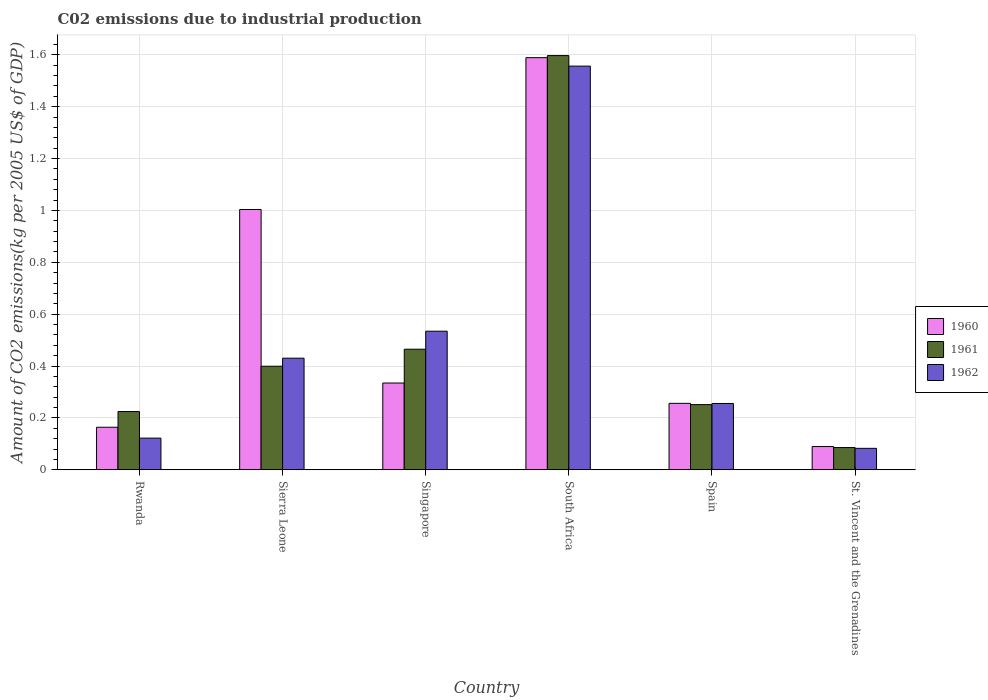How many different coloured bars are there?
Ensure brevity in your answer.  3. Are the number of bars per tick equal to the number of legend labels?
Give a very brief answer. Yes. How many bars are there on the 5th tick from the right?
Provide a short and direct response. 3. What is the label of the 4th group of bars from the left?
Provide a short and direct response. South Africa. In how many cases, is the number of bars for a given country not equal to the number of legend labels?
Ensure brevity in your answer.  0. What is the amount of CO2 emitted due to industrial production in 1962 in Sierra Leone?
Give a very brief answer. 0.43. Across all countries, what is the maximum amount of CO2 emitted due to industrial production in 1962?
Provide a succinct answer. 1.56. Across all countries, what is the minimum amount of CO2 emitted due to industrial production in 1961?
Offer a terse response. 0.09. In which country was the amount of CO2 emitted due to industrial production in 1961 maximum?
Provide a short and direct response. South Africa. In which country was the amount of CO2 emitted due to industrial production in 1961 minimum?
Offer a very short reply. St. Vincent and the Grenadines. What is the total amount of CO2 emitted due to industrial production in 1961 in the graph?
Your answer should be very brief. 3.02. What is the difference between the amount of CO2 emitted due to industrial production in 1961 in Rwanda and that in Singapore?
Your answer should be very brief. -0.24. What is the difference between the amount of CO2 emitted due to industrial production in 1960 in St. Vincent and the Grenadines and the amount of CO2 emitted due to industrial production in 1961 in South Africa?
Your answer should be compact. -1.51. What is the average amount of CO2 emitted due to industrial production in 1962 per country?
Ensure brevity in your answer.  0.5. What is the difference between the amount of CO2 emitted due to industrial production of/in 1960 and amount of CO2 emitted due to industrial production of/in 1962 in Sierra Leone?
Your answer should be very brief. 0.57. In how many countries, is the amount of CO2 emitted due to industrial production in 1961 greater than 0.36 kg?
Offer a very short reply. 3. What is the ratio of the amount of CO2 emitted due to industrial production in 1961 in Sierra Leone to that in Spain?
Make the answer very short. 1.59. Is the amount of CO2 emitted due to industrial production in 1960 in Rwanda less than that in Singapore?
Ensure brevity in your answer.  Yes. What is the difference between the highest and the second highest amount of CO2 emitted due to industrial production in 1962?
Your response must be concise. -1.02. What is the difference between the highest and the lowest amount of CO2 emitted due to industrial production in 1962?
Your response must be concise. 1.47. In how many countries, is the amount of CO2 emitted due to industrial production in 1960 greater than the average amount of CO2 emitted due to industrial production in 1960 taken over all countries?
Your answer should be very brief. 2. Is the sum of the amount of CO2 emitted due to industrial production in 1962 in Rwanda and Sierra Leone greater than the maximum amount of CO2 emitted due to industrial production in 1961 across all countries?
Offer a very short reply. No. What does the 3rd bar from the left in Singapore represents?
Your answer should be compact. 1962. Is it the case that in every country, the sum of the amount of CO2 emitted due to industrial production in 1962 and amount of CO2 emitted due to industrial production in 1960 is greater than the amount of CO2 emitted due to industrial production in 1961?
Keep it short and to the point. Yes. How many bars are there?
Give a very brief answer. 18. Are all the bars in the graph horizontal?
Keep it short and to the point. No. What is the difference between two consecutive major ticks on the Y-axis?
Provide a succinct answer. 0.2. Are the values on the major ticks of Y-axis written in scientific E-notation?
Ensure brevity in your answer.  No. Does the graph contain any zero values?
Keep it short and to the point. No. Does the graph contain grids?
Give a very brief answer. Yes. How many legend labels are there?
Give a very brief answer. 3. How are the legend labels stacked?
Keep it short and to the point. Vertical. What is the title of the graph?
Your answer should be compact. C02 emissions due to industrial production. Does "1970" appear as one of the legend labels in the graph?
Provide a short and direct response. No. What is the label or title of the Y-axis?
Offer a terse response. Amount of CO2 emissions(kg per 2005 US$ of GDP). What is the Amount of CO2 emissions(kg per 2005 US$ of GDP) of 1960 in Rwanda?
Your answer should be compact. 0.16. What is the Amount of CO2 emissions(kg per 2005 US$ of GDP) of 1961 in Rwanda?
Provide a succinct answer. 0.22. What is the Amount of CO2 emissions(kg per 2005 US$ of GDP) in 1962 in Rwanda?
Give a very brief answer. 0.12. What is the Amount of CO2 emissions(kg per 2005 US$ of GDP) of 1960 in Sierra Leone?
Offer a terse response. 1. What is the Amount of CO2 emissions(kg per 2005 US$ of GDP) in 1961 in Sierra Leone?
Offer a terse response. 0.4. What is the Amount of CO2 emissions(kg per 2005 US$ of GDP) in 1962 in Sierra Leone?
Provide a short and direct response. 0.43. What is the Amount of CO2 emissions(kg per 2005 US$ of GDP) in 1960 in Singapore?
Provide a succinct answer. 0.33. What is the Amount of CO2 emissions(kg per 2005 US$ of GDP) in 1961 in Singapore?
Keep it short and to the point. 0.46. What is the Amount of CO2 emissions(kg per 2005 US$ of GDP) of 1962 in Singapore?
Offer a terse response. 0.53. What is the Amount of CO2 emissions(kg per 2005 US$ of GDP) of 1960 in South Africa?
Provide a short and direct response. 1.59. What is the Amount of CO2 emissions(kg per 2005 US$ of GDP) of 1961 in South Africa?
Offer a terse response. 1.6. What is the Amount of CO2 emissions(kg per 2005 US$ of GDP) of 1962 in South Africa?
Your answer should be very brief. 1.56. What is the Amount of CO2 emissions(kg per 2005 US$ of GDP) in 1960 in Spain?
Give a very brief answer. 0.26. What is the Amount of CO2 emissions(kg per 2005 US$ of GDP) of 1961 in Spain?
Give a very brief answer. 0.25. What is the Amount of CO2 emissions(kg per 2005 US$ of GDP) in 1962 in Spain?
Your answer should be compact. 0.26. What is the Amount of CO2 emissions(kg per 2005 US$ of GDP) of 1960 in St. Vincent and the Grenadines?
Offer a very short reply. 0.09. What is the Amount of CO2 emissions(kg per 2005 US$ of GDP) of 1961 in St. Vincent and the Grenadines?
Provide a short and direct response. 0.09. What is the Amount of CO2 emissions(kg per 2005 US$ of GDP) of 1962 in St. Vincent and the Grenadines?
Provide a short and direct response. 0.08. Across all countries, what is the maximum Amount of CO2 emissions(kg per 2005 US$ of GDP) of 1960?
Your answer should be very brief. 1.59. Across all countries, what is the maximum Amount of CO2 emissions(kg per 2005 US$ of GDP) in 1961?
Keep it short and to the point. 1.6. Across all countries, what is the maximum Amount of CO2 emissions(kg per 2005 US$ of GDP) in 1962?
Offer a terse response. 1.56. Across all countries, what is the minimum Amount of CO2 emissions(kg per 2005 US$ of GDP) in 1960?
Offer a terse response. 0.09. Across all countries, what is the minimum Amount of CO2 emissions(kg per 2005 US$ of GDP) of 1961?
Offer a terse response. 0.09. Across all countries, what is the minimum Amount of CO2 emissions(kg per 2005 US$ of GDP) in 1962?
Your response must be concise. 0.08. What is the total Amount of CO2 emissions(kg per 2005 US$ of GDP) in 1960 in the graph?
Offer a terse response. 3.44. What is the total Amount of CO2 emissions(kg per 2005 US$ of GDP) of 1961 in the graph?
Give a very brief answer. 3.02. What is the total Amount of CO2 emissions(kg per 2005 US$ of GDP) of 1962 in the graph?
Ensure brevity in your answer.  2.98. What is the difference between the Amount of CO2 emissions(kg per 2005 US$ of GDP) in 1960 in Rwanda and that in Sierra Leone?
Your answer should be compact. -0.84. What is the difference between the Amount of CO2 emissions(kg per 2005 US$ of GDP) of 1961 in Rwanda and that in Sierra Leone?
Keep it short and to the point. -0.17. What is the difference between the Amount of CO2 emissions(kg per 2005 US$ of GDP) of 1962 in Rwanda and that in Sierra Leone?
Ensure brevity in your answer.  -0.31. What is the difference between the Amount of CO2 emissions(kg per 2005 US$ of GDP) of 1960 in Rwanda and that in Singapore?
Give a very brief answer. -0.17. What is the difference between the Amount of CO2 emissions(kg per 2005 US$ of GDP) in 1961 in Rwanda and that in Singapore?
Provide a short and direct response. -0.24. What is the difference between the Amount of CO2 emissions(kg per 2005 US$ of GDP) of 1962 in Rwanda and that in Singapore?
Provide a succinct answer. -0.41. What is the difference between the Amount of CO2 emissions(kg per 2005 US$ of GDP) of 1960 in Rwanda and that in South Africa?
Ensure brevity in your answer.  -1.42. What is the difference between the Amount of CO2 emissions(kg per 2005 US$ of GDP) in 1961 in Rwanda and that in South Africa?
Provide a short and direct response. -1.37. What is the difference between the Amount of CO2 emissions(kg per 2005 US$ of GDP) in 1962 in Rwanda and that in South Africa?
Your response must be concise. -1.43. What is the difference between the Amount of CO2 emissions(kg per 2005 US$ of GDP) in 1960 in Rwanda and that in Spain?
Keep it short and to the point. -0.09. What is the difference between the Amount of CO2 emissions(kg per 2005 US$ of GDP) in 1961 in Rwanda and that in Spain?
Ensure brevity in your answer.  -0.03. What is the difference between the Amount of CO2 emissions(kg per 2005 US$ of GDP) of 1962 in Rwanda and that in Spain?
Ensure brevity in your answer.  -0.13. What is the difference between the Amount of CO2 emissions(kg per 2005 US$ of GDP) in 1960 in Rwanda and that in St. Vincent and the Grenadines?
Your answer should be compact. 0.07. What is the difference between the Amount of CO2 emissions(kg per 2005 US$ of GDP) in 1961 in Rwanda and that in St. Vincent and the Grenadines?
Offer a terse response. 0.14. What is the difference between the Amount of CO2 emissions(kg per 2005 US$ of GDP) of 1962 in Rwanda and that in St. Vincent and the Grenadines?
Provide a succinct answer. 0.04. What is the difference between the Amount of CO2 emissions(kg per 2005 US$ of GDP) in 1960 in Sierra Leone and that in Singapore?
Ensure brevity in your answer.  0.67. What is the difference between the Amount of CO2 emissions(kg per 2005 US$ of GDP) in 1961 in Sierra Leone and that in Singapore?
Your answer should be compact. -0.07. What is the difference between the Amount of CO2 emissions(kg per 2005 US$ of GDP) of 1962 in Sierra Leone and that in Singapore?
Give a very brief answer. -0.1. What is the difference between the Amount of CO2 emissions(kg per 2005 US$ of GDP) of 1960 in Sierra Leone and that in South Africa?
Your answer should be very brief. -0.59. What is the difference between the Amount of CO2 emissions(kg per 2005 US$ of GDP) in 1961 in Sierra Leone and that in South Africa?
Ensure brevity in your answer.  -1.2. What is the difference between the Amount of CO2 emissions(kg per 2005 US$ of GDP) in 1962 in Sierra Leone and that in South Africa?
Provide a short and direct response. -1.13. What is the difference between the Amount of CO2 emissions(kg per 2005 US$ of GDP) in 1960 in Sierra Leone and that in Spain?
Make the answer very short. 0.75. What is the difference between the Amount of CO2 emissions(kg per 2005 US$ of GDP) of 1961 in Sierra Leone and that in Spain?
Offer a very short reply. 0.15. What is the difference between the Amount of CO2 emissions(kg per 2005 US$ of GDP) of 1962 in Sierra Leone and that in Spain?
Your answer should be very brief. 0.17. What is the difference between the Amount of CO2 emissions(kg per 2005 US$ of GDP) of 1960 in Sierra Leone and that in St. Vincent and the Grenadines?
Keep it short and to the point. 0.91. What is the difference between the Amount of CO2 emissions(kg per 2005 US$ of GDP) in 1961 in Sierra Leone and that in St. Vincent and the Grenadines?
Offer a terse response. 0.31. What is the difference between the Amount of CO2 emissions(kg per 2005 US$ of GDP) in 1962 in Sierra Leone and that in St. Vincent and the Grenadines?
Ensure brevity in your answer.  0.35. What is the difference between the Amount of CO2 emissions(kg per 2005 US$ of GDP) of 1960 in Singapore and that in South Africa?
Keep it short and to the point. -1.25. What is the difference between the Amount of CO2 emissions(kg per 2005 US$ of GDP) of 1961 in Singapore and that in South Africa?
Provide a short and direct response. -1.13. What is the difference between the Amount of CO2 emissions(kg per 2005 US$ of GDP) in 1962 in Singapore and that in South Africa?
Keep it short and to the point. -1.02. What is the difference between the Amount of CO2 emissions(kg per 2005 US$ of GDP) in 1960 in Singapore and that in Spain?
Your answer should be very brief. 0.08. What is the difference between the Amount of CO2 emissions(kg per 2005 US$ of GDP) of 1961 in Singapore and that in Spain?
Keep it short and to the point. 0.21. What is the difference between the Amount of CO2 emissions(kg per 2005 US$ of GDP) in 1962 in Singapore and that in Spain?
Your response must be concise. 0.28. What is the difference between the Amount of CO2 emissions(kg per 2005 US$ of GDP) in 1960 in Singapore and that in St. Vincent and the Grenadines?
Offer a very short reply. 0.24. What is the difference between the Amount of CO2 emissions(kg per 2005 US$ of GDP) in 1961 in Singapore and that in St. Vincent and the Grenadines?
Your answer should be very brief. 0.38. What is the difference between the Amount of CO2 emissions(kg per 2005 US$ of GDP) in 1962 in Singapore and that in St. Vincent and the Grenadines?
Give a very brief answer. 0.45. What is the difference between the Amount of CO2 emissions(kg per 2005 US$ of GDP) of 1960 in South Africa and that in Spain?
Your answer should be very brief. 1.33. What is the difference between the Amount of CO2 emissions(kg per 2005 US$ of GDP) of 1961 in South Africa and that in Spain?
Offer a terse response. 1.35. What is the difference between the Amount of CO2 emissions(kg per 2005 US$ of GDP) of 1962 in South Africa and that in Spain?
Offer a very short reply. 1.3. What is the difference between the Amount of CO2 emissions(kg per 2005 US$ of GDP) of 1960 in South Africa and that in St. Vincent and the Grenadines?
Ensure brevity in your answer.  1.5. What is the difference between the Amount of CO2 emissions(kg per 2005 US$ of GDP) of 1961 in South Africa and that in St. Vincent and the Grenadines?
Offer a terse response. 1.51. What is the difference between the Amount of CO2 emissions(kg per 2005 US$ of GDP) of 1962 in South Africa and that in St. Vincent and the Grenadines?
Provide a succinct answer. 1.47. What is the difference between the Amount of CO2 emissions(kg per 2005 US$ of GDP) in 1960 in Spain and that in St. Vincent and the Grenadines?
Your answer should be compact. 0.17. What is the difference between the Amount of CO2 emissions(kg per 2005 US$ of GDP) in 1961 in Spain and that in St. Vincent and the Grenadines?
Your answer should be compact. 0.17. What is the difference between the Amount of CO2 emissions(kg per 2005 US$ of GDP) in 1962 in Spain and that in St. Vincent and the Grenadines?
Your answer should be very brief. 0.17. What is the difference between the Amount of CO2 emissions(kg per 2005 US$ of GDP) in 1960 in Rwanda and the Amount of CO2 emissions(kg per 2005 US$ of GDP) in 1961 in Sierra Leone?
Ensure brevity in your answer.  -0.24. What is the difference between the Amount of CO2 emissions(kg per 2005 US$ of GDP) in 1960 in Rwanda and the Amount of CO2 emissions(kg per 2005 US$ of GDP) in 1962 in Sierra Leone?
Your response must be concise. -0.27. What is the difference between the Amount of CO2 emissions(kg per 2005 US$ of GDP) in 1961 in Rwanda and the Amount of CO2 emissions(kg per 2005 US$ of GDP) in 1962 in Sierra Leone?
Make the answer very short. -0.21. What is the difference between the Amount of CO2 emissions(kg per 2005 US$ of GDP) in 1960 in Rwanda and the Amount of CO2 emissions(kg per 2005 US$ of GDP) in 1961 in Singapore?
Keep it short and to the point. -0.3. What is the difference between the Amount of CO2 emissions(kg per 2005 US$ of GDP) of 1960 in Rwanda and the Amount of CO2 emissions(kg per 2005 US$ of GDP) of 1962 in Singapore?
Provide a short and direct response. -0.37. What is the difference between the Amount of CO2 emissions(kg per 2005 US$ of GDP) in 1961 in Rwanda and the Amount of CO2 emissions(kg per 2005 US$ of GDP) in 1962 in Singapore?
Give a very brief answer. -0.31. What is the difference between the Amount of CO2 emissions(kg per 2005 US$ of GDP) of 1960 in Rwanda and the Amount of CO2 emissions(kg per 2005 US$ of GDP) of 1961 in South Africa?
Ensure brevity in your answer.  -1.43. What is the difference between the Amount of CO2 emissions(kg per 2005 US$ of GDP) in 1960 in Rwanda and the Amount of CO2 emissions(kg per 2005 US$ of GDP) in 1962 in South Africa?
Provide a short and direct response. -1.39. What is the difference between the Amount of CO2 emissions(kg per 2005 US$ of GDP) in 1961 in Rwanda and the Amount of CO2 emissions(kg per 2005 US$ of GDP) in 1962 in South Africa?
Provide a succinct answer. -1.33. What is the difference between the Amount of CO2 emissions(kg per 2005 US$ of GDP) of 1960 in Rwanda and the Amount of CO2 emissions(kg per 2005 US$ of GDP) of 1961 in Spain?
Provide a succinct answer. -0.09. What is the difference between the Amount of CO2 emissions(kg per 2005 US$ of GDP) in 1960 in Rwanda and the Amount of CO2 emissions(kg per 2005 US$ of GDP) in 1962 in Spain?
Your response must be concise. -0.09. What is the difference between the Amount of CO2 emissions(kg per 2005 US$ of GDP) of 1961 in Rwanda and the Amount of CO2 emissions(kg per 2005 US$ of GDP) of 1962 in Spain?
Make the answer very short. -0.03. What is the difference between the Amount of CO2 emissions(kg per 2005 US$ of GDP) in 1960 in Rwanda and the Amount of CO2 emissions(kg per 2005 US$ of GDP) in 1961 in St. Vincent and the Grenadines?
Give a very brief answer. 0.08. What is the difference between the Amount of CO2 emissions(kg per 2005 US$ of GDP) in 1960 in Rwanda and the Amount of CO2 emissions(kg per 2005 US$ of GDP) in 1962 in St. Vincent and the Grenadines?
Offer a terse response. 0.08. What is the difference between the Amount of CO2 emissions(kg per 2005 US$ of GDP) in 1961 in Rwanda and the Amount of CO2 emissions(kg per 2005 US$ of GDP) in 1962 in St. Vincent and the Grenadines?
Offer a very short reply. 0.14. What is the difference between the Amount of CO2 emissions(kg per 2005 US$ of GDP) in 1960 in Sierra Leone and the Amount of CO2 emissions(kg per 2005 US$ of GDP) in 1961 in Singapore?
Keep it short and to the point. 0.54. What is the difference between the Amount of CO2 emissions(kg per 2005 US$ of GDP) of 1960 in Sierra Leone and the Amount of CO2 emissions(kg per 2005 US$ of GDP) of 1962 in Singapore?
Ensure brevity in your answer.  0.47. What is the difference between the Amount of CO2 emissions(kg per 2005 US$ of GDP) in 1961 in Sierra Leone and the Amount of CO2 emissions(kg per 2005 US$ of GDP) in 1962 in Singapore?
Provide a short and direct response. -0.14. What is the difference between the Amount of CO2 emissions(kg per 2005 US$ of GDP) of 1960 in Sierra Leone and the Amount of CO2 emissions(kg per 2005 US$ of GDP) of 1961 in South Africa?
Offer a very short reply. -0.59. What is the difference between the Amount of CO2 emissions(kg per 2005 US$ of GDP) of 1960 in Sierra Leone and the Amount of CO2 emissions(kg per 2005 US$ of GDP) of 1962 in South Africa?
Your answer should be compact. -0.55. What is the difference between the Amount of CO2 emissions(kg per 2005 US$ of GDP) in 1961 in Sierra Leone and the Amount of CO2 emissions(kg per 2005 US$ of GDP) in 1962 in South Africa?
Your answer should be compact. -1.16. What is the difference between the Amount of CO2 emissions(kg per 2005 US$ of GDP) in 1960 in Sierra Leone and the Amount of CO2 emissions(kg per 2005 US$ of GDP) in 1961 in Spain?
Your response must be concise. 0.75. What is the difference between the Amount of CO2 emissions(kg per 2005 US$ of GDP) in 1960 in Sierra Leone and the Amount of CO2 emissions(kg per 2005 US$ of GDP) in 1962 in Spain?
Provide a short and direct response. 0.75. What is the difference between the Amount of CO2 emissions(kg per 2005 US$ of GDP) in 1961 in Sierra Leone and the Amount of CO2 emissions(kg per 2005 US$ of GDP) in 1962 in Spain?
Make the answer very short. 0.14. What is the difference between the Amount of CO2 emissions(kg per 2005 US$ of GDP) of 1960 in Sierra Leone and the Amount of CO2 emissions(kg per 2005 US$ of GDP) of 1961 in St. Vincent and the Grenadines?
Provide a succinct answer. 0.92. What is the difference between the Amount of CO2 emissions(kg per 2005 US$ of GDP) in 1960 in Sierra Leone and the Amount of CO2 emissions(kg per 2005 US$ of GDP) in 1962 in St. Vincent and the Grenadines?
Give a very brief answer. 0.92. What is the difference between the Amount of CO2 emissions(kg per 2005 US$ of GDP) of 1961 in Sierra Leone and the Amount of CO2 emissions(kg per 2005 US$ of GDP) of 1962 in St. Vincent and the Grenadines?
Offer a terse response. 0.32. What is the difference between the Amount of CO2 emissions(kg per 2005 US$ of GDP) in 1960 in Singapore and the Amount of CO2 emissions(kg per 2005 US$ of GDP) in 1961 in South Africa?
Provide a short and direct response. -1.26. What is the difference between the Amount of CO2 emissions(kg per 2005 US$ of GDP) in 1960 in Singapore and the Amount of CO2 emissions(kg per 2005 US$ of GDP) in 1962 in South Africa?
Provide a short and direct response. -1.22. What is the difference between the Amount of CO2 emissions(kg per 2005 US$ of GDP) in 1961 in Singapore and the Amount of CO2 emissions(kg per 2005 US$ of GDP) in 1962 in South Africa?
Your answer should be very brief. -1.09. What is the difference between the Amount of CO2 emissions(kg per 2005 US$ of GDP) of 1960 in Singapore and the Amount of CO2 emissions(kg per 2005 US$ of GDP) of 1961 in Spain?
Keep it short and to the point. 0.08. What is the difference between the Amount of CO2 emissions(kg per 2005 US$ of GDP) of 1960 in Singapore and the Amount of CO2 emissions(kg per 2005 US$ of GDP) of 1962 in Spain?
Keep it short and to the point. 0.08. What is the difference between the Amount of CO2 emissions(kg per 2005 US$ of GDP) in 1961 in Singapore and the Amount of CO2 emissions(kg per 2005 US$ of GDP) in 1962 in Spain?
Your response must be concise. 0.21. What is the difference between the Amount of CO2 emissions(kg per 2005 US$ of GDP) in 1960 in Singapore and the Amount of CO2 emissions(kg per 2005 US$ of GDP) in 1961 in St. Vincent and the Grenadines?
Make the answer very short. 0.25. What is the difference between the Amount of CO2 emissions(kg per 2005 US$ of GDP) in 1960 in Singapore and the Amount of CO2 emissions(kg per 2005 US$ of GDP) in 1962 in St. Vincent and the Grenadines?
Ensure brevity in your answer.  0.25. What is the difference between the Amount of CO2 emissions(kg per 2005 US$ of GDP) of 1961 in Singapore and the Amount of CO2 emissions(kg per 2005 US$ of GDP) of 1962 in St. Vincent and the Grenadines?
Give a very brief answer. 0.38. What is the difference between the Amount of CO2 emissions(kg per 2005 US$ of GDP) of 1960 in South Africa and the Amount of CO2 emissions(kg per 2005 US$ of GDP) of 1961 in Spain?
Your response must be concise. 1.34. What is the difference between the Amount of CO2 emissions(kg per 2005 US$ of GDP) of 1960 in South Africa and the Amount of CO2 emissions(kg per 2005 US$ of GDP) of 1962 in Spain?
Offer a very short reply. 1.33. What is the difference between the Amount of CO2 emissions(kg per 2005 US$ of GDP) of 1961 in South Africa and the Amount of CO2 emissions(kg per 2005 US$ of GDP) of 1962 in Spain?
Your answer should be compact. 1.34. What is the difference between the Amount of CO2 emissions(kg per 2005 US$ of GDP) in 1960 in South Africa and the Amount of CO2 emissions(kg per 2005 US$ of GDP) in 1961 in St. Vincent and the Grenadines?
Give a very brief answer. 1.5. What is the difference between the Amount of CO2 emissions(kg per 2005 US$ of GDP) in 1960 in South Africa and the Amount of CO2 emissions(kg per 2005 US$ of GDP) in 1962 in St. Vincent and the Grenadines?
Provide a succinct answer. 1.51. What is the difference between the Amount of CO2 emissions(kg per 2005 US$ of GDP) of 1961 in South Africa and the Amount of CO2 emissions(kg per 2005 US$ of GDP) of 1962 in St. Vincent and the Grenadines?
Make the answer very short. 1.51. What is the difference between the Amount of CO2 emissions(kg per 2005 US$ of GDP) of 1960 in Spain and the Amount of CO2 emissions(kg per 2005 US$ of GDP) of 1961 in St. Vincent and the Grenadines?
Provide a succinct answer. 0.17. What is the difference between the Amount of CO2 emissions(kg per 2005 US$ of GDP) in 1960 in Spain and the Amount of CO2 emissions(kg per 2005 US$ of GDP) in 1962 in St. Vincent and the Grenadines?
Your response must be concise. 0.17. What is the difference between the Amount of CO2 emissions(kg per 2005 US$ of GDP) of 1961 in Spain and the Amount of CO2 emissions(kg per 2005 US$ of GDP) of 1962 in St. Vincent and the Grenadines?
Provide a succinct answer. 0.17. What is the average Amount of CO2 emissions(kg per 2005 US$ of GDP) in 1960 per country?
Provide a short and direct response. 0.57. What is the average Amount of CO2 emissions(kg per 2005 US$ of GDP) in 1961 per country?
Your response must be concise. 0.5. What is the average Amount of CO2 emissions(kg per 2005 US$ of GDP) of 1962 per country?
Make the answer very short. 0.5. What is the difference between the Amount of CO2 emissions(kg per 2005 US$ of GDP) of 1960 and Amount of CO2 emissions(kg per 2005 US$ of GDP) of 1961 in Rwanda?
Provide a succinct answer. -0.06. What is the difference between the Amount of CO2 emissions(kg per 2005 US$ of GDP) in 1960 and Amount of CO2 emissions(kg per 2005 US$ of GDP) in 1962 in Rwanda?
Give a very brief answer. 0.04. What is the difference between the Amount of CO2 emissions(kg per 2005 US$ of GDP) of 1961 and Amount of CO2 emissions(kg per 2005 US$ of GDP) of 1962 in Rwanda?
Your answer should be very brief. 0.1. What is the difference between the Amount of CO2 emissions(kg per 2005 US$ of GDP) in 1960 and Amount of CO2 emissions(kg per 2005 US$ of GDP) in 1961 in Sierra Leone?
Ensure brevity in your answer.  0.6. What is the difference between the Amount of CO2 emissions(kg per 2005 US$ of GDP) in 1960 and Amount of CO2 emissions(kg per 2005 US$ of GDP) in 1962 in Sierra Leone?
Your answer should be compact. 0.57. What is the difference between the Amount of CO2 emissions(kg per 2005 US$ of GDP) of 1961 and Amount of CO2 emissions(kg per 2005 US$ of GDP) of 1962 in Sierra Leone?
Offer a very short reply. -0.03. What is the difference between the Amount of CO2 emissions(kg per 2005 US$ of GDP) of 1960 and Amount of CO2 emissions(kg per 2005 US$ of GDP) of 1961 in Singapore?
Keep it short and to the point. -0.13. What is the difference between the Amount of CO2 emissions(kg per 2005 US$ of GDP) in 1960 and Amount of CO2 emissions(kg per 2005 US$ of GDP) in 1962 in Singapore?
Your answer should be very brief. -0.2. What is the difference between the Amount of CO2 emissions(kg per 2005 US$ of GDP) in 1961 and Amount of CO2 emissions(kg per 2005 US$ of GDP) in 1962 in Singapore?
Offer a terse response. -0.07. What is the difference between the Amount of CO2 emissions(kg per 2005 US$ of GDP) in 1960 and Amount of CO2 emissions(kg per 2005 US$ of GDP) in 1961 in South Africa?
Ensure brevity in your answer.  -0.01. What is the difference between the Amount of CO2 emissions(kg per 2005 US$ of GDP) in 1960 and Amount of CO2 emissions(kg per 2005 US$ of GDP) in 1962 in South Africa?
Offer a terse response. 0.03. What is the difference between the Amount of CO2 emissions(kg per 2005 US$ of GDP) in 1961 and Amount of CO2 emissions(kg per 2005 US$ of GDP) in 1962 in South Africa?
Your answer should be very brief. 0.04. What is the difference between the Amount of CO2 emissions(kg per 2005 US$ of GDP) of 1960 and Amount of CO2 emissions(kg per 2005 US$ of GDP) of 1961 in Spain?
Offer a very short reply. 0. What is the difference between the Amount of CO2 emissions(kg per 2005 US$ of GDP) in 1960 and Amount of CO2 emissions(kg per 2005 US$ of GDP) in 1962 in Spain?
Make the answer very short. 0. What is the difference between the Amount of CO2 emissions(kg per 2005 US$ of GDP) in 1961 and Amount of CO2 emissions(kg per 2005 US$ of GDP) in 1962 in Spain?
Offer a terse response. -0. What is the difference between the Amount of CO2 emissions(kg per 2005 US$ of GDP) of 1960 and Amount of CO2 emissions(kg per 2005 US$ of GDP) of 1961 in St. Vincent and the Grenadines?
Give a very brief answer. 0. What is the difference between the Amount of CO2 emissions(kg per 2005 US$ of GDP) of 1960 and Amount of CO2 emissions(kg per 2005 US$ of GDP) of 1962 in St. Vincent and the Grenadines?
Provide a short and direct response. 0.01. What is the difference between the Amount of CO2 emissions(kg per 2005 US$ of GDP) of 1961 and Amount of CO2 emissions(kg per 2005 US$ of GDP) of 1962 in St. Vincent and the Grenadines?
Keep it short and to the point. 0. What is the ratio of the Amount of CO2 emissions(kg per 2005 US$ of GDP) of 1960 in Rwanda to that in Sierra Leone?
Your answer should be compact. 0.16. What is the ratio of the Amount of CO2 emissions(kg per 2005 US$ of GDP) of 1961 in Rwanda to that in Sierra Leone?
Keep it short and to the point. 0.56. What is the ratio of the Amount of CO2 emissions(kg per 2005 US$ of GDP) in 1962 in Rwanda to that in Sierra Leone?
Your answer should be compact. 0.28. What is the ratio of the Amount of CO2 emissions(kg per 2005 US$ of GDP) of 1960 in Rwanda to that in Singapore?
Ensure brevity in your answer.  0.49. What is the ratio of the Amount of CO2 emissions(kg per 2005 US$ of GDP) of 1961 in Rwanda to that in Singapore?
Provide a succinct answer. 0.48. What is the ratio of the Amount of CO2 emissions(kg per 2005 US$ of GDP) of 1962 in Rwanda to that in Singapore?
Keep it short and to the point. 0.23. What is the ratio of the Amount of CO2 emissions(kg per 2005 US$ of GDP) of 1960 in Rwanda to that in South Africa?
Provide a succinct answer. 0.1. What is the ratio of the Amount of CO2 emissions(kg per 2005 US$ of GDP) in 1961 in Rwanda to that in South Africa?
Ensure brevity in your answer.  0.14. What is the ratio of the Amount of CO2 emissions(kg per 2005 US$ of GDP) of 1962 in Rwanda to that in South Africa?
Offer a terse response. 0.08. What is the ratio of the Amount of CO2 emissions(kg per 2005 US$ of GDP) in 1960 in Rwanda to that in Spain?
Provide a succinct answer. 0.64. What is the ratio of the Amount of CO2 emissions(kg per 2005 US$ of GDP) in 1961 in Rwanda to that in Spain?
Offer a terse response. 0.89. What is the ratio of the Amount of CO2 emissions(kg per 2005 US$ of GDP) in 1962 in Rwanda to that in Spain?
Give a very brief answer. 0.48. What is the ratio of the Amount of CO2 emissions(kg per 2005 US$ of GDP) of 1960 in Rwanda to that in St. Vincent and the Grenadines?
Your answer should be very brief. 1.83. What is the ratio of the Amount of CO2 emissions(kg per 2005 US$ of GDP) of 1961 in Rwanda to that in St. Vincent and the Grenadines?
Keep it short and to the point. 2.62. What is the ratio of the Amount of CO2 emissions(kg per 2005 US$ of GDP) in 1962 in Rwanda to that in St. Vincent and the Grenadines?
Ensure brevity in your answer.  1.48. What is the ratio of the Amount of CO2 emissions(kg per 2005 US$ of GDP) in 1960 in Sierra Leone to that in Singapore?
Offer a very short reply. 3. What is the ratio of the Amount of CO2 emissions(kg per 2005 US$ of GDP) in 1961 in Sierra Leone to that in Singapore?
Ensure brevity in your answer.  0.86. What is the ratio of the Amount of CO2 emissions(kg per 2005 US$ of GDP) in 1962 in Sierra Leone to that in Singapore?
Offer a terse response. 0.81. What is the ratio of the Amount of CO2 emissions(kg per 2005 US$ of GDP) in 1960 in Sierra Leone to that in South Africa?
Offer a terse response. 0.63. What is the ratio of the Amount of CO2 emissions(kg per 2005 US$ of GDP) of 1961 in Sierra Leone to that in South Africa?
Your answer should be compact. 0.25. What is the ratio of the Amount of CO2 emissions(kg per 2005 US$ of GDP) in 1962 in Sierra Leone to that in South Africa?
Your response must be concise. 0.28. What is the ratio of the Amount of CO2 emissions(kg per 2005 US$ of GDP) of 1960 in Sierra Leone to that in Spain?
Make the answer very short. 3.92. What is the ratio of the Amount of CO2 emissions(kg per 2005 US$ of GDP) of 1961 in Sierra Leone to that in Spain?
Your answer should be very brief. 1.59. What is the ratio of the Amount of CO2 emissions(kg per 2005 US$ of GDP) of 1962 in Sierra Leone to that in Spain?
Offer a very short reply. 1.68. What is the ratio of the Amount of CO2 emissions(kg per 2005 US$ of GDP) in 1960 in Sierra Leone to that in St. Vincent and the Grenadines?
Make the answer very short. 11.19. What is the ratio of the Amount of CO2 emissions(kg per 2005 US$ of GDP) in 1961 in Sierra Leone to that in St. Vincent and the Grenadines?
Provide a short and direct response. 4.65. What is the ratio of the Amount of CO2 emissions(kg per 2005 US$ of GDP) in 1962 in Sierra Leone to that in St. Vincent and the Grenadines?
Your answer should be compact. 5.2. What is the ratio of the Amount of CO2 emissions(kg per 2005 US$ of GDP) in 1960 in Singapore to that in South Africa?
Provide a short and direct response. 0.21. What is the ratio of the Amount of CO2 emissions(kg per 2005 US$ of GDP) of 1961 in Singapore to that in South Africa?
Your answer should be very brief. 0.29. What is the ratio of the Amount of CO2 emissions(kg per 2005 US$ of GDP) in 1962 in Singapore to that in South Africa?
Your response must be concise. 0.34. What is the ratio of the Amount of CO2 emissions(kg per 2005 US$ of GDP) in 1960 in Singapore to that in Spain?
Ensure brevity in your answer.  1.31. What is the ratio of the Amount of CO2 emissions(kg per 2005 US$ of GDP) in 1961 in Singapore to that in Spain?
Give a very brief answer. 1.85. What is the ratio of the Amount of CO2 emissions(kg per 2005 US$ of GDP) of 1962 in Singapore to that in Spain?
Give a very brief answer. 2.09. What is the ratio of the Amount of CO2 emissions(kg per 2005 US$ of GDP) in 1960 in Singapore to that in St. Vincent and the Grenadines?
Make the answer very short. 3.73. What is the ratio of the Amount of CO2 emissions(kg per 2005 US$ of GDP) in 1961 in Singapore to that in St. Vincent and the Grenadines?
Give a very brief answer. 5.42. What is the ratio of the Amount of CO2 emissions(kg per 2005 US$ of GDP) of 1962 in Singapore to that in St. Vincent and the Grenadines?
Provide a succinct answer. 6.46. What is the ratio of the Amount of CO2 emissions(kg per 2005 US$ of GDP) of 1960 in South Africa to that in Spain?
Provide a succinct answer. 6.2. What is the ratio of the Amount of CO2 emissions(kg per 2005 US$ of GDP) in 1961 in South Africa to that in Spain?
Provide a succinct answer. 6.35. What is the ratio of the Amount of CO2 emissions(kg per 2005 US$ of GDP) of 1962 in South Africa to that in Spain?
Your answer should be very brief. 6.09. What is the ratio of the Amount of CO2 emissions(kg per 2005 US$ of GDP) in 1960 in South Africa to that in St. Vincent and the Grenadines?
Your answer should be very brief. 17.72. What is the ratio of the Amount of CO2 emissions(kg per 2005 US$ of GDP) of 1961 in South Africa to that in St. Vincent and the Grenadines?
Offer a terse response. 18.61. What is the ratio of the Amount of CO2 emissions(kg per 2005 US$ of GDP) in 1962 in South Africa to that in St. Vincent and the Grenadines?
Offer a very short reply. 18.81. What is the ratio of the Amount of CO2 emissions(kg per 2005 US$ of GDP) in 1960 in Spain to that in St. Vincent and the Grenadines?
Offer a terse response. 2.86. What is the ratio of the Amount of CO2 emissions(kg per 2005 US$ of GDP) in 1961 in Spain to that in St. Vincent and the Grenadines?
Your answer should be very brief. 2.93. What is the ratio of the Amount of CO2 emissions(kg per 2005 US$ of GDP) of 1962 in Spain to that in St. Vincent and the Grenadines?
Offer a very short reply. 3.09. What is the difference between the highest and the second highest Amount of CO2 emissions(kg per 2005 US$ of GDP) of 1960?
Ensure brevity in your answer.  0.59. What is the difference between the highest and the second highest Amount of CO2 emissions(kg per 2005 US$ of GDP) in 1961?
Provide a short and direct response. 1.13. What is the difference between the highest and the second highest Amount of CO2 emissions(kg per 2005 US$ of GDP) of 1962?
Give a very brief answer. 1.02. What is the difference between the highest and the lowest Amount of CO2 emissions(kg per 2005 US$ of GDP) of 1960?
Offer a very short reply. 1.5. What is the difference between the highest and the lowest Amount of CO2 emissions(kg per 2005 US$ of GDP) of 1961?
Your answer should be compact. 1.51. What is the difference between the highest and the lowest Amount of CO2 emissions(kg per 2005 US$ of GDP) of 1962?
Make the answer very short. 1.47. 